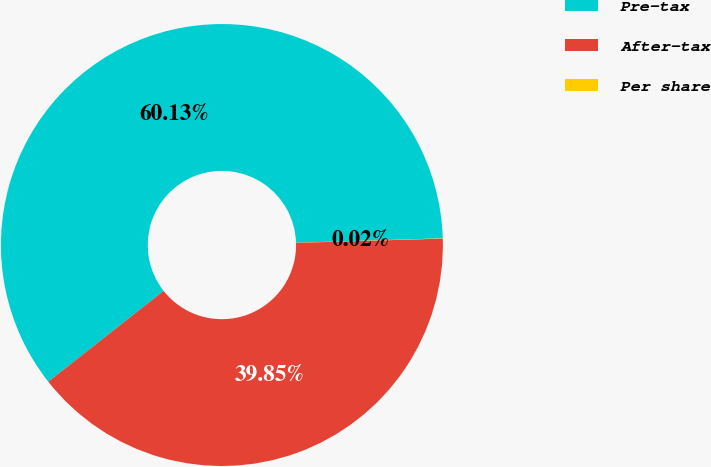Convert chart. <chart><loc_0><loc_0><loc_500><loc_500><pie_chart><fcel>Pre-tax<fcel>After-tax<fcel>Per share<nl><fcel>60.13%<fcel>39.85%<fcel>0.02%<nl></chart> 